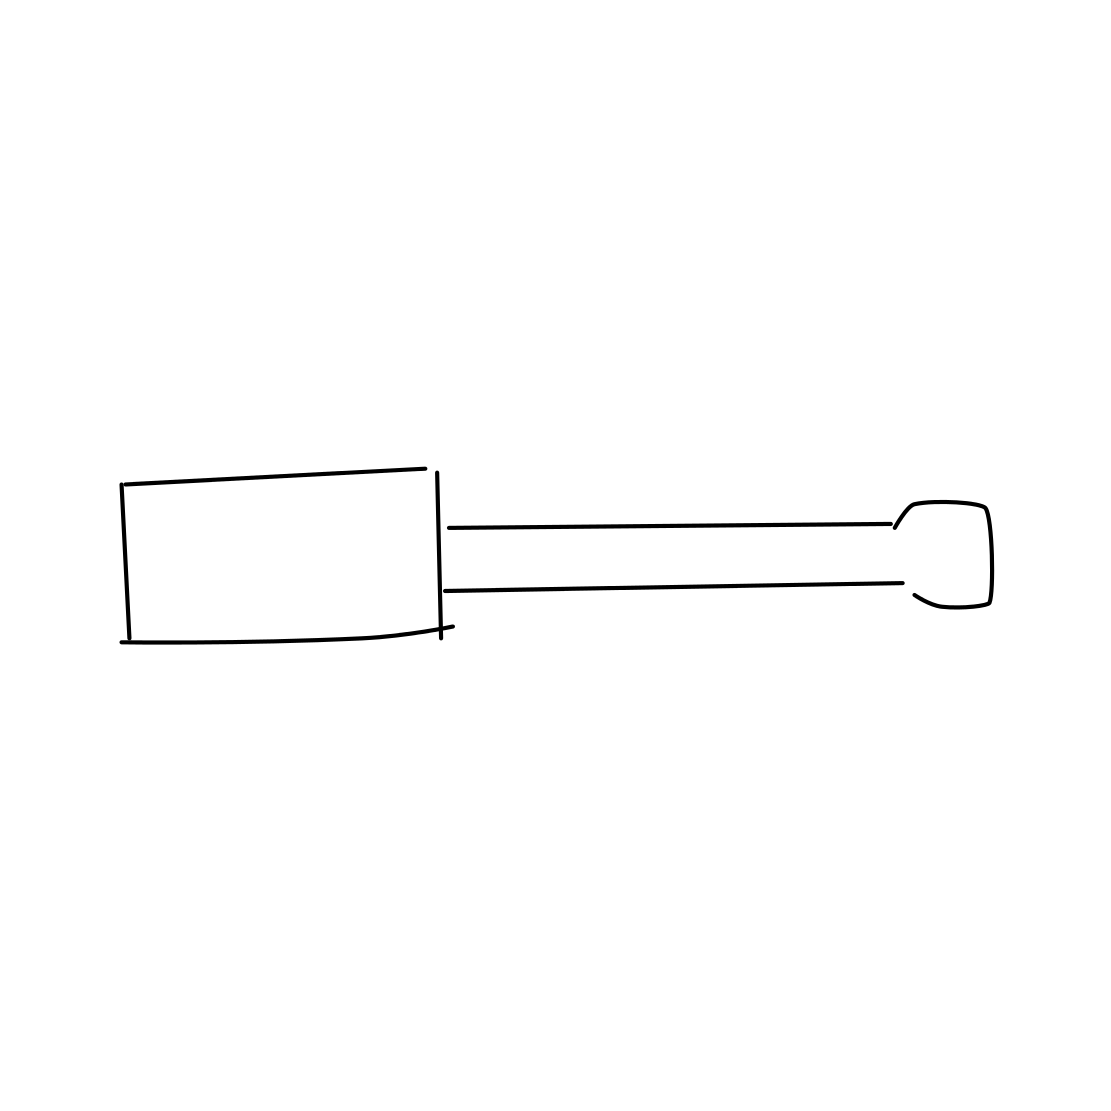In the scene, is a screwdriver in it? Yes, the image clearly depicts a screwdriver with a distinct handle and a pointed tip, which is typically used for driving screws into materials or for making adjustments to mechanical devices. 